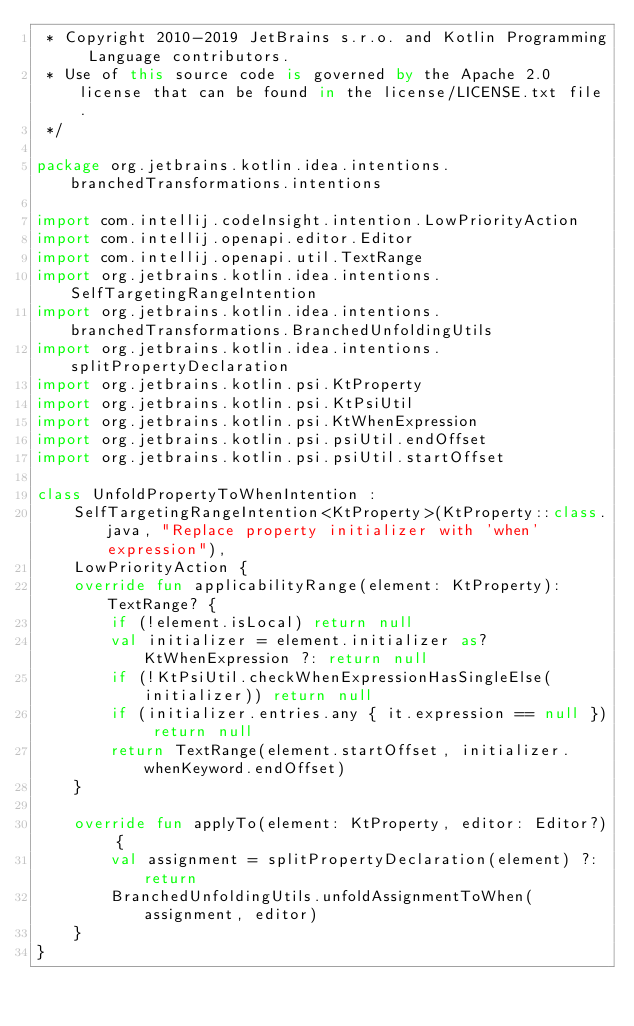<code> <loc_0><loc_0><loc_500><loc_500><_Kotlin_> * Copyright 2010-2019 JetBrains s.r.o. and Kotlin Programming Language contributors.
 * Use of this source code is governed by the Apache 2.0 license that can be found in the license/LICENSE.txt file.
 */

package org.jetbrains.kotlin.idea.intentions.branchedTransformations.intentions

import com.intellij.codeInsight.intention.LowPriorityAction
import com.intellij.openapi.editor.Editor
import com.intellij.openapi.util.TextRange
import org.jetbrains.kotlin.idea.intentions.SelfTargetingRangeIntention
import org.jetbrains.kotlin.idea.intentions.branchedTransformations.BranchedUnfoldingUtils
import org.jetbrains.kotlin.idea.intentions.splitPropertyDeclaration
import org.jetbrains.kotlin.psi.KtProperty
import org.jetbrains.kotlin.psi.KtPsiUtil
import org.jetbrains.kotlin.psi.KtWhenExpression
import org.jetbrains.kotlin.psi.psiUtil.endOffset
import org.jetbrains.kotlin.psi.psiUtil.startOffset

class UnfoldPropertyToWhenIntention :
    SelfTargetingRangeIntention<KtProperty>(KtProperty::class.java, "Replace property initializer with 'when' expression"),
    LowPriorityAction {
    override fun applicabilityRange(element: KtProperty): TextRange? {
        if (!element.isLocal) return null
        val initializer = element.initializer as? KtWhenExpression ?: return null
        if (!KtPsiUtil.checkWhenExpressionHasSingleElse(initializer)) return null
        if (initializer.entries.any { it.expression == null }) return null
        return TextRange(element.startOffset, initializer.whenKeyword.endOffset)
    }

    override fun applyTo(element: KtProperty, editor: Editor?) {
        val assignment = splitPropertyDeclaration(element) ?: return
        BranchedUnfoldingUtils.unfoldAssignmentToWhen(assignment, editor)
    }
}</code> 